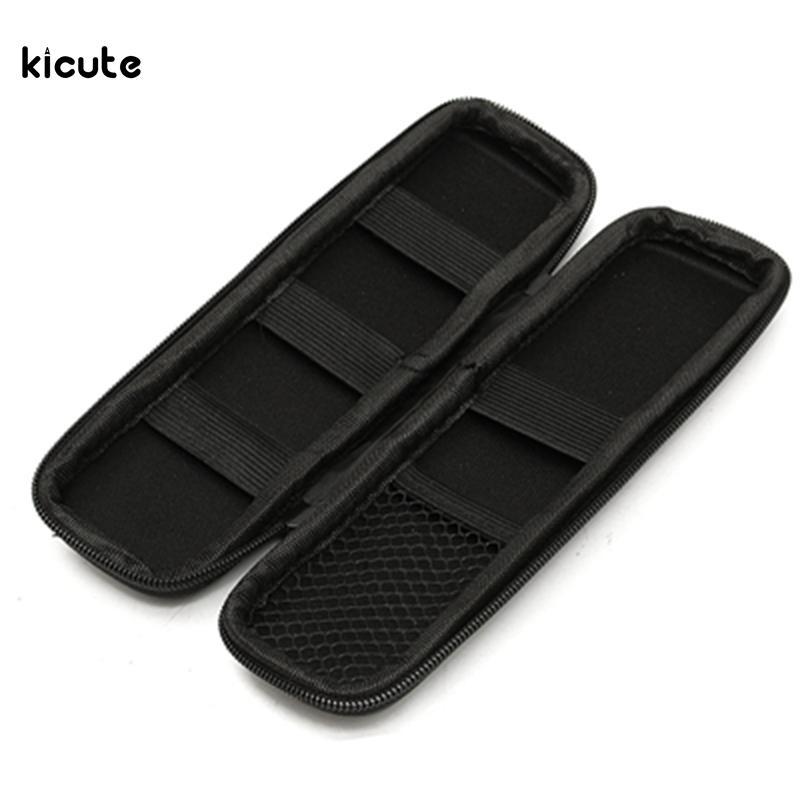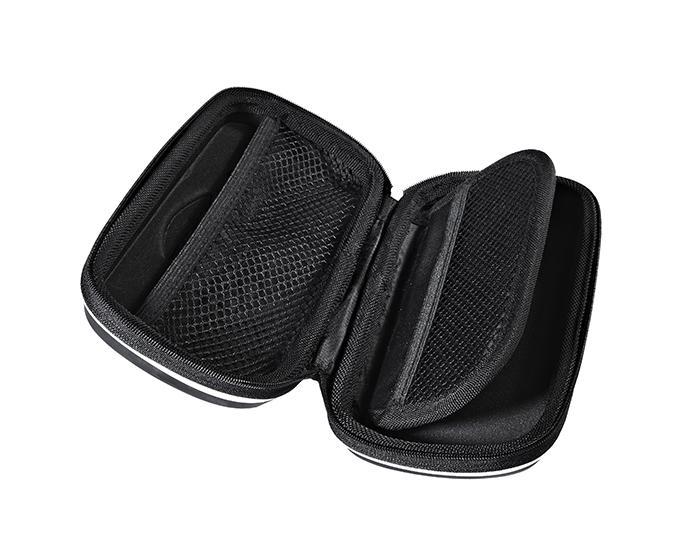The first image is the image on the left, the second image is the image on the right. Examine the images to the left and right. Is the description "The black pencil case on the left is closed and has raised dots on its front, and the case on the right is also closed." accurate? Answer yes or no. No. The first image is the image on the left, the second image is the image on the right. Assess this claim about the two images: "there is a pencil pouch with raised bumps in varying sizes on it". Correct or not? Answer yes or no. No. 